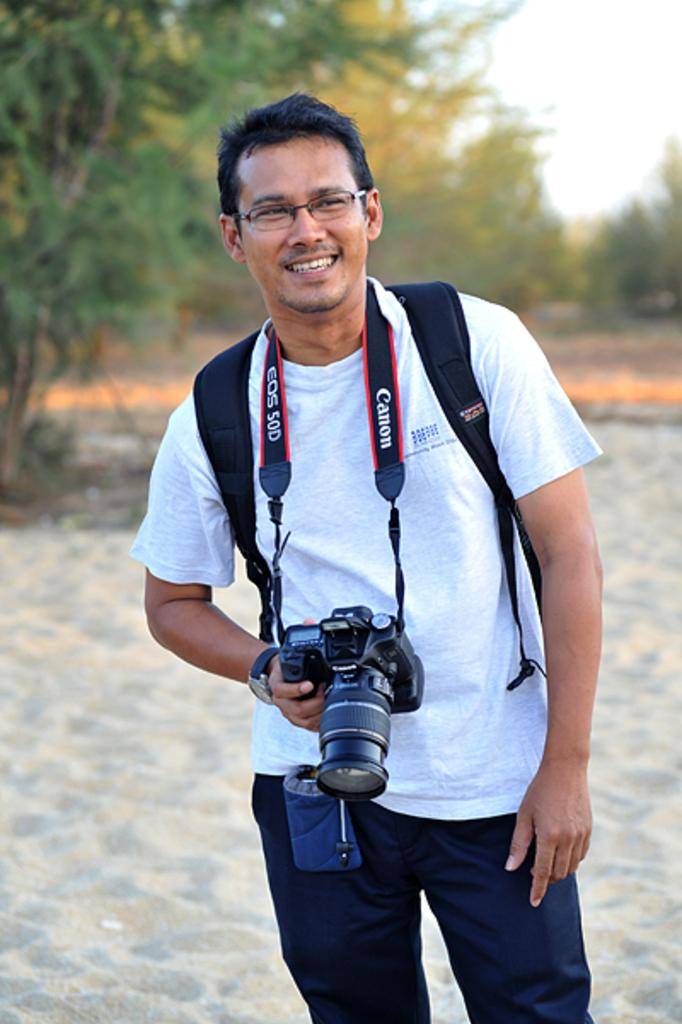What is the main subject of the image? There is a person in the image. What is the person doing in the image? The person is standing and smiling. What accessories is the person wearing in the image? The person is wearing a camera around their neck and a watch. What can be seen in the background of the image? The sky is visible behind the person, and there are trees visible in the image. What is the size of the water body visible in the image? There is no water body visible in the image; it only features a person, trees, and the sky. In which direction is the person facing in the image? The direction the person is facing cannot be determined from the image alone, as there is no reference point to indicate north or any other direction. 